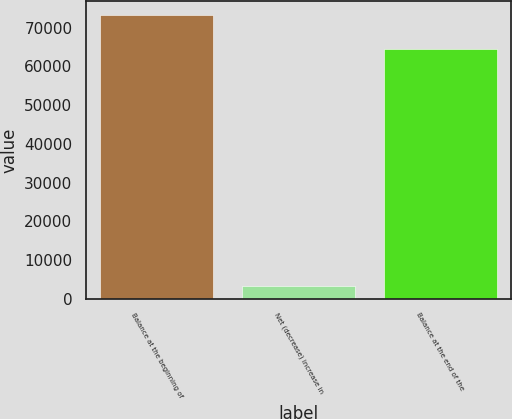Convert chart to OTSL. <chart><loc_0><loc_0><loc_500><loc_500><bar_chart><fcel>Balance at the beginning of<fcel>Net (decrease) increase in<fcel>Balance at the end of the<nl><fcel>73199<fcel>3184<fcel>64390<nl></chart> 